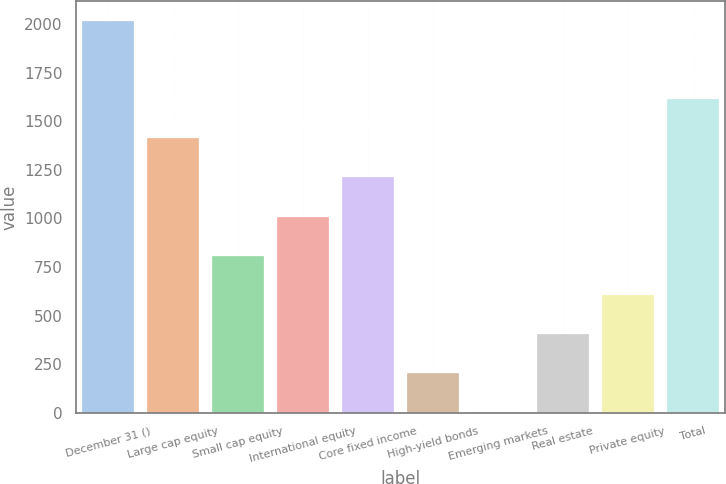Convert chart to OTSL. <chart><loc_0><loc_0><loc_500><loc_500><bar_chart><fcel>December 31 ()<fcel>Large cap equity<fcel>Small cap equity<fcel>International equity<fcel>Core fixed income<fcel>High-yield bonds<fcel>Emerging markets<fcel>Real estate<fcel>Private equity<fcel>Total<nl><fcel>2017<fcel>1412.5<fcel>808<fcel>1009.5<fcel>1211<fcel>203.5<fcel>2<fcel>405<fcel>606.5<fcel>1614<nl></chart> 